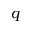<formula> <loc_0><loc_0><loc_500><loc_500>q</formula> 